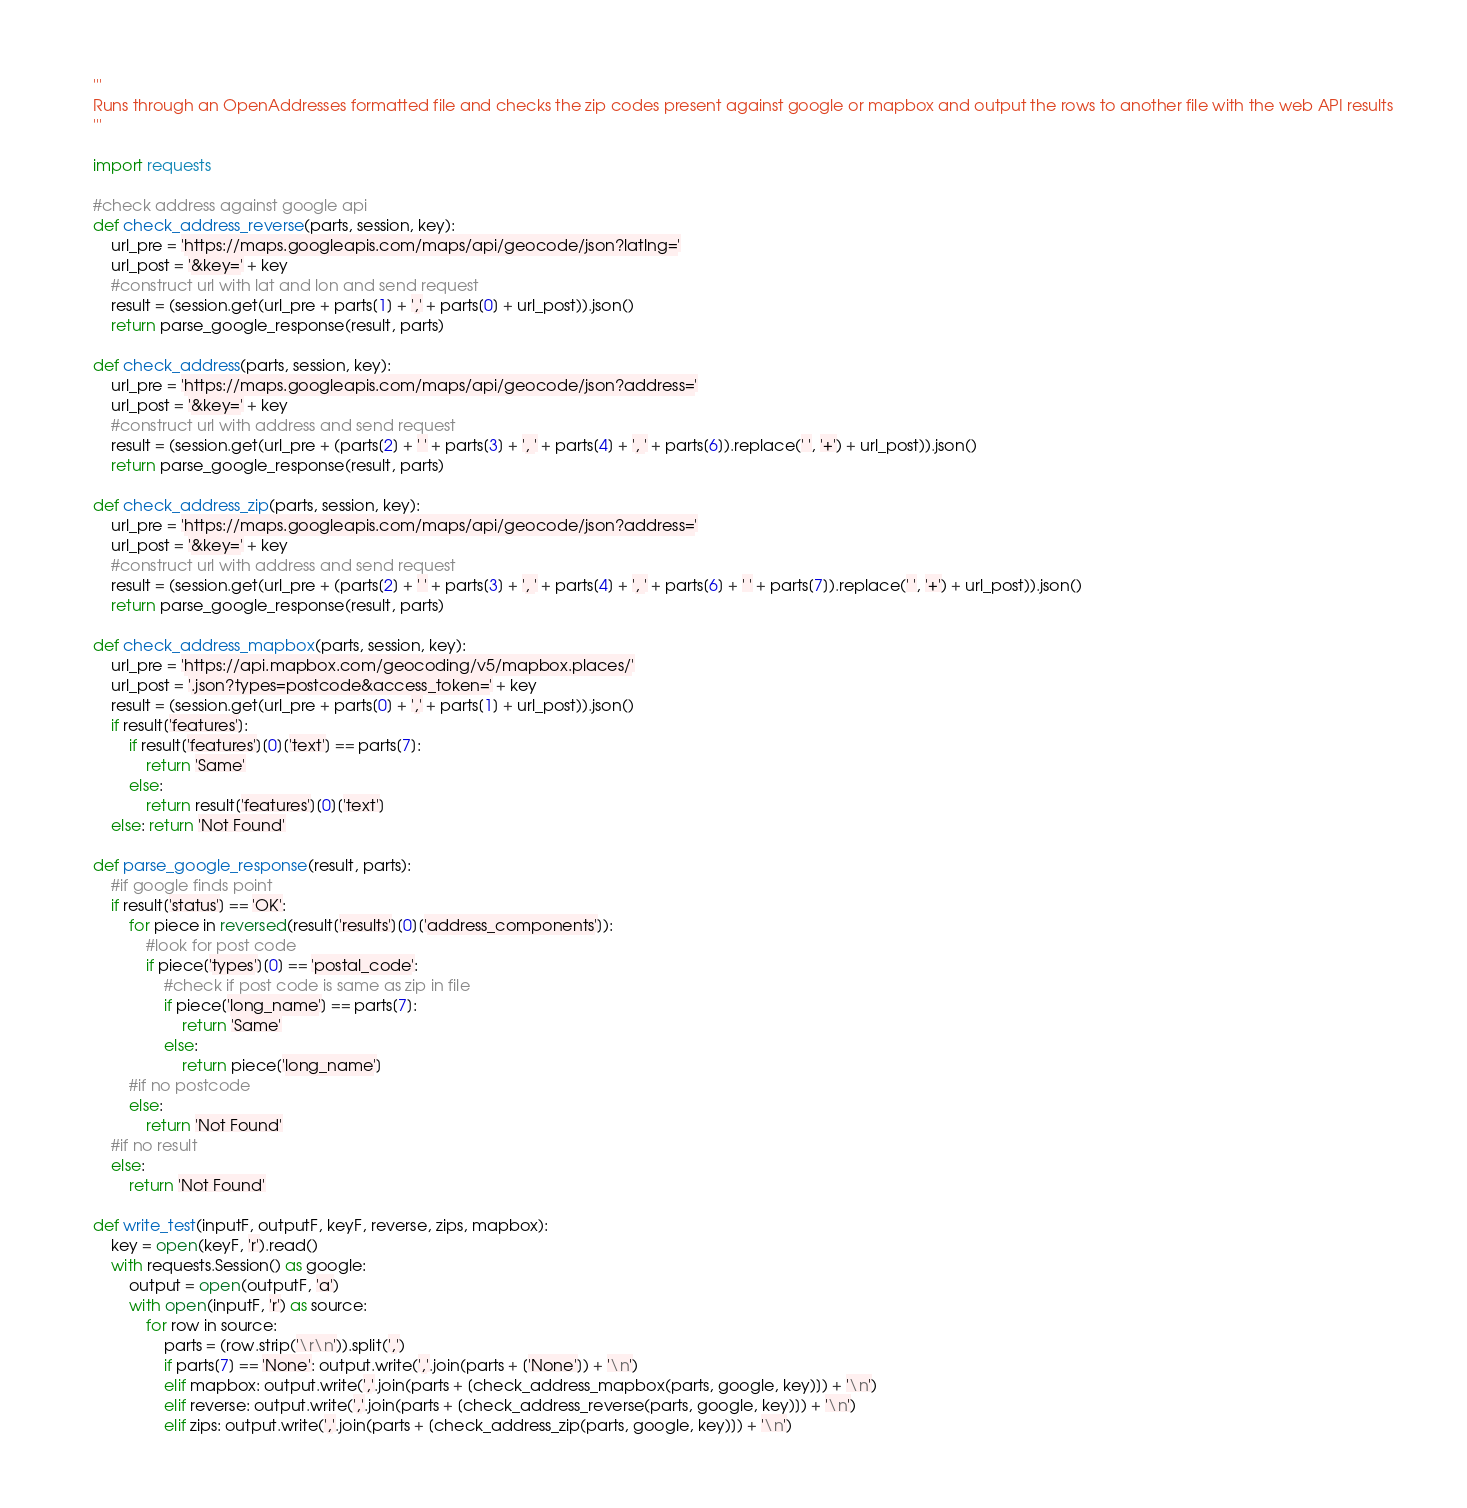<code> <loc_0><loc_0><loc_500><loc_500><_Python_>'''
Runs through an OpenAddresses formatted file and checks the zip codes present against google or mapbox and output the rows to another file with the web API results
'''

import requests

#check address against google api
def check_address_reverse(parts, session, key):
	url_pre = 'https://maps.googleapis.com/maps/api/geocode/json?latlng='
	url_post = '&key=' + key
	#construct url with lat and lon and send request
	result = (session.get(url_pre + parts[1] + ',' + parts[0] + url_post)).json()
	return parse_google_response(result, parts)

def check_address(parts, session, key):
	url_pre = 'https://maps.googleapis.com/maps/api/geocode/json?address='
	url_post = '&key=' + key
	#construct url with address and send request
	result = (session.get(url_pre + (parts[2] + ' ' + parts[3] + ', ' + parts[4] + ', ' + parts[6]).replace(' ', '+') + url_post)).json()
	return parse_google_response(result, parts)

def check_address_zip(parts, session, key):
	url_pre = 'https://maps.googleapis.com/maps/api/geocode/json?address='
	url_post = '&key=' + key
	#construct url with address and send request
	result = (session.get(url_pre + (parts[2] + ' ' + parts[3] + ', ' + parts[4] + ', ' + parts[6] + ' ' + parts[7]).replace(' ', '+') + url_post)).json()
	return parse_google_response(result, parts)

def check_address_mapbox(parts, session, key):
	url_pre = 'https://api.mapbox.com/geocoding/v5/mapbox.places/'
	url_post = '.json?types=postcode&access_token=' + key
	result = (session.get(url_pre + parts[0] + ',' + parts[1] + url_post)).json()
	if result['features']:
		if result['features'][0]['text'] == parts[7]:
			return 'Same'
		else:
			return result['features'][0]['text']
	else: return 'Not Found'
	
def parse_google_response(result, parts):
	#if google finds point
	if result['status'] == 'OK':
		for piece in reversed(result['results'][0]['address_components']):
			#look for post code
			if piece['types'][0] == 'postal_code':
				#check if post code is same as zip in file
				if piece['long_name'] == parts[7]:
					return 'Same'
				else:
					return piece['long_name']
		#if no postcode
		else:
			return 'Not Found'
	#if no result
	else:
		return 'Not Found'

def write_test(inputF, outputF, keyF, reverse, zips, mapbox):
	key = open(keyF, 'r').read()
	with requests.Session() as google:
		output = open(outputF, 'a')
		with open(inputF, 'r') as source:
			for row in source:
				parts = (row.strip('\r\n')).split(',')
				if parts[7] == 'None': output.write(','.join(parts + ['None']) + '\n')
				elif mapbox: output.write(','.join(parts + [check_address_mapbox(parts, google, key)]) + '\n')
				elif reverse: output.write(','.join(parts + [check_address_reverse(parts, google, key)]) + '\n')
				elif zips: output.write(','.join(parts + [check_address_zip(parts, google, key)]) + '\n')</code> 